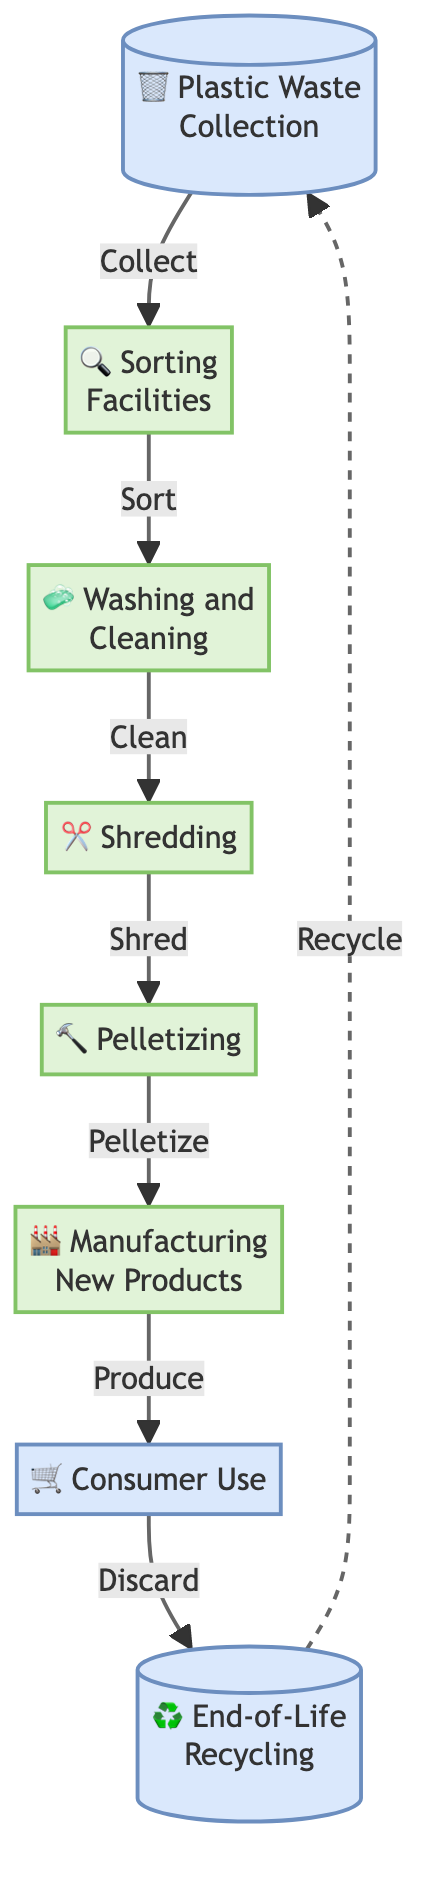What is the first step in the recycling process? The flow chart indicates that the first step is "Plastic Waste Collection". This is the initial action that initiates the entire recycling process.
Answer: Plastic Waste Collection How many main stages are there in this flow chart? By counting the nodes of the flow chart, there are eight main stages that represent different parts of the recycling process.
Answer: 8 What does the sorting facilities do? The sorting facilities are responsible for categorizing the collected plastic waste into different types, such as PET, HDPE, and PVC. This sorting is crucial for the efficiency of the recycling process.
Answer: Sort into different types What is the final stage before a product is recycled again? The final stage before recycling is "End-of-Life Recycling", which refers to the collection of the product once its lifecycle is completed.
Answer: End-of-Life Recycling Which stage directly follows washing and cleaning? The stage that directly follows washing and cleaning, as per the flow of the diagram, is shredding. This step is essential for processing the cleaned plastics into smaller pieces.
Answer: Shredding What happens after consumer use of the product? After consumer use, the product is discarded, and this leads to the "End-of-Life Recycling" stage, where it is collected for potential recycling again.
Answer: Discard What is the result of the pelletizing process? The pelletizing process results in the creation of pellets from shredded plastics, making them easier to transport and reuse in manufacturing new products.
Answer: Pellets What relationship exists between manufacturing new products and consumer use? Manufacturing new products leads to consumer use, indicating that the products created from recycled materials are then purchased and utilized by consumers.
Answer: Produce What is the role of washing and cleaning in the process? Washing and cleaning play a critical role in ensuring that the sorted plastics are free from contaminants, which enhances the quality of the recycled materials.
Answer: Remove contaminants 